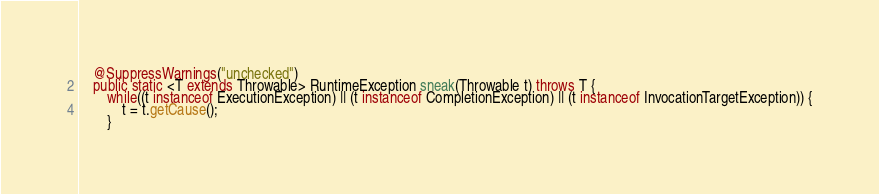<code> <loc_0><loc_0><loc_500><loc_500><_Java_>
    @SuppressWarnings("unchecked")
    public static <T extends Throwable> RuntimeException sneak(Throwable t) throws T {
        while((t instanceof ExecutionException) || (t instanceof CompletionException) || (t instanceof InvocationTargetException)) {
            t = t.getCause();
        }</code> 